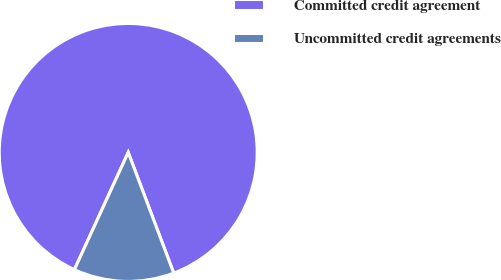<chart> <loc_0><loc_0><loc_500><loc_500><pie_chart><fcel>Committed credit agreement<fcel>Uncommitted credit agreements<nl><fcel>87.41%<fcel>12.59%<nl></chart> 